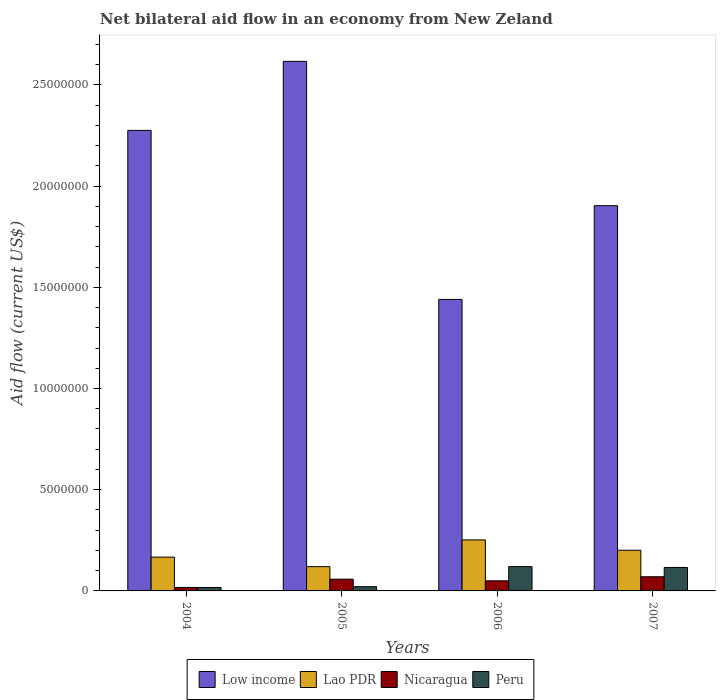Are the number of bars on each tick of the X-axis equal?
Ensure brevity in your answer.  Yes. How many bars are there on the 3rd tick from the left?
Keep it short and to the point. 4. What is the label of the 1st group of bars from the left?
Give a very brief answer. 2004. What is the net bilateral aid flow in Peru in 2006?
Offer a terse response. 1.20e+06. Across all years, what is the maximum net bilateral aid flow in Peru?
Offer a very short reply. 1.20e+06. Across all years, what is the minimum net bilateral aid flow in Low income?
Offer a very short reply. 1.44e+07. What is the total net bilateral aid flow in Peru in the graph?
Make the answer very short. 2.74e+06. What is the difference between the net bilateral aid flow in Lao PDR in 2005 and that in 2006?
Make the answer very short. -1.32e+06. What is the difference between the net bilateral aid flow in Peru in 2005 and the net bilateral aid flow in Low income in 2006?
Your answer should be compact. -1.42e+07. What is the average net bilateral aid flow in Nicaragua per year?
Your answer should be very brief. 4.88e+05. In the year 2005, what is the difference between the net bilateral aid flow in Nicaragua and net bilateral aid flow in Low income?
Your answer should be very brief. -2.56e+07. In how many years, is the net bilateral aid flow in Nicaragua greater than 22000000 US$?
Your answer should be compact. 0. What is the ratio of the net bilateral aid flow in Nicaragua in 2005 to that in 2006?
Make the answer very short. 1.16. Is the net bilateral aid flow in Nicaragua in 2004 less than that in 2006?
Your answer should be compact. Yes. Is the difference between the net bilateral aid flow in Nicaragua in 2004 and 2005 greater than the difference between the net bilateral aid flow in Low income in 2004 and 2005?
Your answer should be very brief. Yes. What is the difference between the highest and the second highest net bilateral aid flow in Peru?
Provide a short and direct response. 4.00e+04. What is the difference between the highest and the lowest net bilateral aid flow in Low income?
Provide a succinct answer. 1.18e+07. Is the sum of the net bilateral aid flow in Lao PDR in 2005 and 2006 greater than the maximum net bilateral aid flow in Low income across all years?
Provide a short and direct response. No. What does the 2nd bar from the left in 2005 represents?
Keep it short and to the point. Lao PDR. What does the 3rd bar from the right in 2005 represents?
Give a very brief answer. Lao PDR. Is it the case that in every year, the sum of the net bilateral aid flow in Low income and net bilateral aid flow in Peru is greater than the net bilateral aid flow in Lao PDR?
Keep it short and to the point. Yes. How many bars are there?
Provide a short and direct response. 16. Are all the bars in the graph horizontal?
Offer a very short reply. No. How many years are there in the graph?
Offer a terse response. 4. Are the values on the major ticks of Y-axis written in scientific E-notation?
Make the answer very short. No. Does the graph contain grids?
Your response must be concise. No. How many legend labels are there?
Make the answer very short. 4. How are the legend labels stacked?
Keep it short and to the point. Horizontal. What is the title of the graph?
Ensure brevity in your answer.  Net bilateral aid flow in an economy from New Zeland. Does "Mauritania" appear as one of the legend labels in the graph?
Offer a terse response. No. What is the Aid flow (current US$) in Low income in 2004?
Offer a terse response. 2.28e+07. What is the Aid flow (current US$) of Lao PDR in 2004?
Offer a terse response. 1.67e+06. What is the Aid flow (current US$) in Peru in 2004?
Give a very brief answer. 1.70e+05. What is the Aid flow (current US$) in Low income in 2005?
Provide a succinct answer. 2.62e+07. What is the Aid flow (current US$) in Lao PDR in 2005?
Ensure brevity in your answer.  1.20e+06. What is the Aid flow (current US$) of Nicaragua in 2005?
Your response must be concise. 5.80e+05. What is the Aid flow (current US$) in Peru in 2005?
Provide a succinct answer. 2.10e+05. What is the Aid flow (current US$) in Low income in 2006?
Keep it short and to the point. 1.44e+07. What is the Aid flow (current US$) of Lao PDR in 2006?
Give a very brief answer. 2.52e+06. What is the Aid flow (current US$) in Nicaragua in 2006?
Your answer should be compact. 5.00e+05. What is the Aid flow (current US$) of Peru in 2006?
Provide a short and direct response. 1.20e+06. What is the Aid flow (current US$) in Low income in 2007?
Offer a terse response. 1.90e+07. What is the Aid flow (current US$) in Lao PDR in 2007?
Your answer should be very brief. 2.01e+06. What is the Aid flow (current US$) of Peru in 2007?
Offer a very short reply. 1.16e+06. Across all years, what is the maximum Aid flow (current US$) in Low income?
Give a very brief answer. 2.62e+07. Across all years, what is the maximum Aid flow (current US$) of Lao PDR?
Offer a very short reply. 2.52e+06. Across all years, what is the maximum Aid flow (current US$) of Peru?
Offer a very short reply. 1.20e+06. Across all years, what is the minimum Aid flow (current US$) in Low income?
Provide a succinct answer. 1.44e+07. Across all years, what is the minimum Aid flow (current US$) in Lao PDR?
Make the answer very short. 1.20e+06. Across all years, what is the minimum Aid flow (current US$) in Nicaragua?
Your answer should be compact. 1.70e+05. Across all years, what is the minimum Aid flow (current US$) of Peru?
Offer a terse response. 1.70e+05. What is the total Aid flow (current US$) in Low income in the graph?
Provide a short and direct response. 8.23e+07. What is the total Aid flow (current US$) of Lao PDR in the graph?
Ensure brevity in your answer.  7.40e+06. What is the total Aid flow (current US$) in Nicaragua in the graph?
Give a very brief answer. 1.95e+06. What is the total Aid flow (current US$) in Peru in the graph?
Keep it short and to the point. 2.74e+06. What is the difference between the Aid flow (current US$) of Low income in 2004 and that in 2005?
Keep it short and to the point. -3.41e+06. What is the difference between the Aid flow (current US$) in Lao PDR in 2004 and that in 2005?
Give a very brief answer. 4.70e+05. What is the difference between the Aid flow (current US$) in Nicaragua in 2004 and that in 2005?
Offer a terse response. -4.10e+05. What is the difference between the Aid flow (current US$) in Low income in 2004 and that in 2006?
Offer a terse response. 8.35e+06. What is the difference between the Aid flow (current US$) of Lao PDR in 2004 and that in 2006?
Provide a succinct answer. -8.50e+05. What is the difference between the Aid flow (current US$) of Nicaragua in 2004 and that in 2006?
Offer a very short reply. -3.30e+05. What is the difference between the Aid flow (current US$) in Peru in 2004 and that in 2006?
Make the answer very short. -1.03e+06. What is the difference between the Aid flow (current US$) in Low income in 2004 and that in 2007?
Make the answer very short. 3.72e+06. What is the difference between the Aid flow (current US$) in Lao PDR in 2004 and that in 2007?
Offer a terse response. -3.40e+05. What is the difference between the Aid flow (current US$) of Nicaragua in 2004 and that in 2007?
Your answer should be compact. -5.30e+05. What is the difference between the Aid flow (current US$) of Peru in 2004 and that in 2007?
Your answer should be very brief. -9.90e+05. What is the difference between the Aid flow (current US$) in Low income in 2005 and that in 2006?
Give a very brief answer. 1.18e+07. What is the difference between the Aid flow (current US$) of Lao PDR in 2005 and that in 2006?
Your answer should be compact. -1.32e+06. What is the difference between the Aid flow (current US$) of Nicaragua in 2005 and that in 2006?
Give a very brief answer. 8.00e+04. What is the difference between the Aid flow (current US$) in Peru in 2005 and that in 2006?
Offer a very short reply. -9.90e+05. What is the difference between the Aid flow (current US$) in Low income in 2005 and that in 2007?
Give a very brief answer. 7.13e+06. What is the difference between the Aid flow (current US$) of Lao PDR in 2005 and that in 2007?
Keep it short and to the point. -8.10e+05. What is the difference between the Aid flow (current US$) of Peru in 2005 and that in 2007?
Give a very brief answer. -9.50e+05. What is the difference between the Aid flow (current US$) in Low income in 2006 and that in 2007?
Offer a terse response. -4.63e+06. What is the difference between the Aid flow (current US$) in Lao PDR in 2006 and that in 2007?
Offer a terse response. 5.10e+05. What is the difference between the Aid flow (current US$) in Nicaragua in 2006 and that in 2007?
Ensure brevity in your answer.  -2.00e+05. What is the difference between the Aid flow (current US$) in Peru in 2006 and that in 2007?
Your response must be concise. 4.00e+04. What is the difference between the Aid flow (current US$) in Low income in 2004 and the Aid flow (current US$) in Lao PDR in 2005?
Your answer should be compact. 2.16e+07. What is the difference between the Aid flow (current US$) in Low income in 2004 and the Aid flow (current US$) in Nicaragua in 2005?
Ensure brevity in your answer.  2.22e+07. What is the difference between the Aid flow (current US$) of Low income in 2004 and the Aid flow (current US$) of Peru in 2005?
Offer a terse response. 2.25e+07. What is the difference between the Aid flow (current US$) of Lao PDR in 2004 and the Aid flow (current US$) of Nicaragua in 2005?
Your answer should be compact. 1.09e+06. What is the difference between the Aid flow (current US$) in Lao PDR in 2004 and the Aid flow (current US$) in Peru in 2005?
Offer a terse response. 1.46e+06. What is the difference between the Aid flow (current US$) in Nicaragua in 2004 and the Aid flow (current US$) in Peru in 2005?
Your answer should be compact. -4.00e+04. What is the difference between the Aid flow (current US$) of Low income in 2004 and the Aid flow (current US$) of Lao PDR in 2006?
Provide a short and direct response. 2.02e+07. What is the difference between the Aid flow (current US$) of Low income in 2004 and the Aid flow (current US$) of Nicaragua in 2006?
Your answer should be compact. 2.22e+07. What is the difference between the Aid flow (current US$) in Low income in 2004 and the Aid flow (current US$) in Peru in 2006?
Your response must be concise. 2.16e+07. What is the difference between the Aid flow (current US$) of Lao PDR in 2004 and the Aid flow (current US$) of Nicaragua in 2006?
Your answer should be very brief. 1.17e+06. What is the difference between the Aid flow (current US$) of Lao PDR in 2004 and the Aid flow (current US$) of Peru in 2006?
Offer a very short reply. 4.70e+05. What is the difference between the Aid flow (current US$) of Nicaragua in 2004 and the Aid flow (current US$) of Peru in 2006?
Keep it short and to the point. -1.03e+06. What is the difference between the Aid flow (current US$) in Low income in 2004 and the Aid flow (current US$) in Lao PDR in 2007?
Provide a succinct answer. 2.07e+07. What is the difference between the Aid flow (current US$) in Low income in 2004 and the Aid flow (current US$) in Nicaragua in 2007?
Your response must be concise. 2.20e+07. What is the difference between the Aid flow (current US$) in Low income in 2004 and the Aid flow (current US$) in Peru in 2007?
Keep it short and to the point. 2.16e+07. What is the difference between the Aid flow (current US$) in Lao PDR in 2004 and the Aid flow (current US$) in Nicaragua in 2007?
Provide a short and direct response. 9.70e+05. What is the difference between the Aid flow (current US$) of Lao PDR in 2004 and the Aid flow (current US$) of Peru in 2007?
Offer a very short reply. 5.10e+05. What is the difference between the Aid flow (current US$) in Nicaragua in 2004 and the Aid flow (current US$) in Peru in 2007?
Offer a very short reply. -9.90e+05. What is the difference between the Aid flow (current US$) in Low income in 2005 and the Aid flow (current US$) in Lao PDR in 2006?
Give a very brief answer. 2.36e+07. What is the difference between the Aid flow (current US$) of Low income in 2005 and the Aid flow (current US$) of Nicaragua in 2006?
Provide a succinct answer. 2.57e+07. What is the difference between the Aid flow (current US$) of Low income in 2005 and the Aid flow (current US$) of Peru in 2006?
Ensure brevity in your answer.  2.50e+07. What is the difference between the Aid flow (current US$) of Lao PDR in 2005 and the Aid flow (current US$) of Peru in 2006?
Provide a succinct answer. 0. What is the difference between the Aid flow (current US$) in Nicaragua in 2005 and the Aid flow (current US$) in Peru in 2006?
Ensure brevity in your answer.  -6.20e+05. What is the difference between the Aid flow (current US$) of Low income in 2005 and the Aid flow (current US$) of Lao PDR in 2007?
Keep it short and to the point. 2.42e+07. What is the difference between the Aid flow (current US$) in Low income in 2005 and the Aid flow (current US$) in Nicaragua in 2007?
Provide a succinct answer. 2.55e+07. What is the difference between the Aid flow (current US$) of Low income in 2005 and the Aid flow (current US$) of Peru in 2007?
Offer a very short reply. 2.50e+07. What is the difference between the Aid flow (current US$) of Lao PDR in 2005 and the Aid flow (current US$) of Nicaragua in 2007?
Provide a short and direct response. 5.00e+05. What is the difference between the Aid flow (current US$) of Nicaragua in 2005 and the Aid flow (current US$) of Peru in 2007?
Keep it short and to the point. -5.80e+05. What is the difference between the Aid flow (current US$) in Low income in 2006 and the Aid flow (current US$) in Lao PDR in 2007?
Make the answer very short. 1.24e+07. What is the difference between the Aid flow (current US$) of Low income in 2006 and the Aid flow (current US$) of Nicaragua in 2007?
Your response must be concise. 1.37e+07. What is the difference between the Aid flow (current US$) in Low income in 2006 and the Aid flow (current US$) in Peru in 2007?
Your answer should be compact. 1.32e+07. What is the difference between the Aid flow (current US$) of Lao PDR in 2006 and the Aid flow (current US$) of Nicaragua in 2007?
Offer a terse response. 1.82e+06. What is the difference between the Aid flow (current US$) of Lao PDR in 2006 and the Aid flow (current US$) of Peru in 2007?
Make the answer very short. 1.36e+06. What is the difference between the Aid flow (current US$) in Nicaragua in 2006 and the Aid flow (current US$) in Peru in 2007?
Give a very brief answer. -6.60e+05. What is the average Aid flow (current US$) in Low income per year?
Offer a terse response. 2.06e+07. What is the average Aid flow (current US$) in Lao PDR per year?
Make the answer very short. 1.85e+06. What is the average Aid flow (current US$) in Nicaragua per year?
Make the answer very short. 4.88e+05. What is the average Aid flow (current US$) in Peru per year?
Provide a short and direct response. 6.85e+05. In the year 2004, what is the difference between the Aid flow (current US$) in Low income and Aid flow (current US$) in Lao PDR?
Offer a terse response. 2.11e+07. In the year 2004, what is the difference between the Aid flow (current US$) of Low income and Aid flow (current US$) of Nicaragua?
Offer a very short reply. 2.26e+07. In the year 2004, what is the difference between the Aid flow (current US$) in Low income and Aid flow (current US$) in Peru?
Offer a very short reply. 2.26e+07. In the year 2004, what is the difference between the Aid flow (current US$) in Lao PDR and Aid flow (current US$) in Nicaragua?
Make the answer very short. 1.50e+06. In the year 2004, what is the difference between the Aid flow (current US$) in Lao PDR and Aid flow (current US$) in Peru?
Your answer should be very brief. 1.50e+06. In the year 2005, what is the difference between the Aid flow (current US$) in Low income and Aid flow (current US$) in Lao PDR?
Provide a succinct answer. 2.50e+07. In the year 2005, what is the difference between the Aid flow (current US$) in Low income and Aid flow (current US$) in Nicaragua?
Your answer should be compact. 2.56e+07. In the year 2005, what is the difference between the Aid flow (current US$) of Low income and Aid flow (current US$) of Peru?
Your response must be concise. 2.60e+07. In the year 2005, what is the difference between the Aid flow (current US$) in Lao PDR and Aid flow (current US$) in Nicaragua?
Your response must be concise. 6.20e+05. In the year 2005, what is the difference between the Aid flow (current US$) of Lao PDR and Aid flow (current US$) of Peru?
Offer a terse response. 9.90e+05. In the year 2006, what is the difference between the Aid flow (current US$) in Low income and Aid flow (current US$) in Lao PDR?
Offer a very short reply. 1.19e+07. In the year 2006, what is the difference between the Aid flow (current US$) in Low income and Aid flow (current US$) in Nicaragua?
Provide a succinct answer. 1.39e+07. In the year 2006, what is the difference between the Aid flow (current US$) in Low income and Aid flow (current US$) in Peru?
Provide a succinct answer. 1.32e+07. In the year 2006, what is the difference between the Aid flow (current US$) in Lao PDR and Aid flow (current US$) in Nicaragua?
Offer a very short reply. 2.02e+06. In the year 2006, what is the difference between the Aid flow (current US$) in Lao PDR and Aid flow (current US$) in Peru?
Make the answer very short. 1.32e+06. In the year 2006, what is the difference between the Aid flow (current US$) in Nicaragua and Aid flow (current US$) in Peru?
Offer a very short reply. -7.00e+05. In the year 2007, what is the difference between the Aid flow (current US$) of Low income and Aid flow (current US$) of Lao PDR?
Your response must be concise. 1.70e+07. In the year 2007, what is the difference between the Aid flow (current US$) of Low income and Aid flow (current US$) of Nicaragua?
Give a very brief answer. 1.83e+07. In the year 2007, what is the difference between the Aid flow (current US$) of Low income and Aid flow (current US$) of Peru?
Provide a short and direct response. 1.79e+07. In the year 2007, what is the difference between the Aid flow (current US$) in Lao PDR and Aid flow (current US$) in Nicaragua?
Offer a very short reply. 1.31e+06. In the year 2007, what is the difference between the Aid flow (current US$) of Lao PDR and Aid flow (current US$) of Peru?
Your response must be concise. 8.50e+05. In the year 2007, what is the difference between the Aid flow (current US$) in Nicaragua and Aid flow (current US$) in Peru?
Your answer should be very brief. -4.60e+05. What is the ratio of the Aid flow (current US$) of Low income in 2004 to that in 2005?
Provide a short and direct response. 0.87. What is the ratio of the Aid flow (current US$) of Lao PDR in 2004 to that in 2005?
Ensure brevity in your answer.  1.39. What is the ratio of the Aid flow (current US$) of Nicaragua in 2004 to that in 2005?
Ensure brevity in your answer.  0.29. What is the ratio of the Aid flow (current US$) of Peru in 2004 to that in 2005?
Provide a short and direct response. 0.81. What is the ratio of the Aid flow (current US$) in Low income in 2004 to that in 2006?
Give a very brief answer. 1.58. What is the ratio of the Aid flow (current US$) in Lao PDR in 2004 to that in 2006?
Offer a terse response. 0.66. What is the ratio of the Aid flow (current US$) in Nicaragua in 2004 to that in 2006?
Provide a short and direct response. 0.34. What is the ratio of the Aid flow (current US$) of Peru in 2004 to that in 2006?
Offer a very short reply. 0.14. What is the ratio of the Aid flow (current US$) in Low income in 2004 to that in 2007?
Keep it short and to the point. 1.2. What is the ratio of the Aid flow (current US$) of Lao PDR in 2004 to that in 2007?
Provide a succinct answer. 0.83. What is the ratio of the Aid flow (current US$) of Nicaragua in 2004 to that in 2007?
Give a very brief answer. 0.24. What is the ratio of the Aid flow (current US$) of Peru in 2004 to that in 2007?
Provide a short and direct response. 0.15. What is the ratio of the Aid flow (current US$) in Low income in 2005 to that in 2006?
Offer a terse response. 1.82. What is the ratio of the Aid flow (current US$) in Lao PDR in 2005 to that in 2006?
Offer a terse response. 0.48. What is the ratio of the Aid flow (current US$) in Nicaragua in 2005 to that in 2006?
Your response must be concise. 1.16. What is the ratio of the Aid flow (current US$) in Peru in 2005 to that in 2006?
Make the answer very short. 0.17. What is the ratio of the Aid flow (current US$) of Low income in 2005 to that in 2007?
Offer a terse response. 1.37. What is the ratio of the Aid flow (current US$) of Lao PDR in 2005 to that in 2007?
Your response must be concise. 0.6. What is the ratio of the Aid flow (current US$) of Nicaragua in 2005 to that in 2007?
Your response must be concise. 0.83. What is the ratio of the Aid flow (current US$) in Peru in 2005 to that in 2007?
Keep it short and to the point. 0.18. What is the ratio of the Aid flow (current US$) in Low income in 2006 to that in 2007?
Provide a short and direct response. 0.76. What is the ratio of the Aid flow (current US$) in Lao PDR in 2006 to that in 2007?
Provide a succinct answer. 1.25. What is the ratio of the Aid flow (current US$) in Peru in 2006 to that in 2007?
Offer a very short reply. 1.03. What is the difference between the highest and the second highest Aid flow (current US$) in Low income?
Give a very brief answer. 3.41e+06. What is the difference between the highest and the second highest Aid flow (current US$) in Lao PDR?
Provide a succinct answer. 5.10e+05. What is the difference between the highest and the lowest Aid flow (current US$) of Low income?
Offer a very short reply. 1.18e+07. What is the difference between the highest and the lowest Aid flow (current US$) of Lao PDR?
Your response must be concise. 1.32e+06. What is the difference between the highest and the lowest Aid flow (current US$) of Nicaragua?
Offer a terse response. 5.30e+05. What is the difference between the highest and the lowest Aid flow (current US$) in Peru?
Make the answer very short. 1.03e+06. 